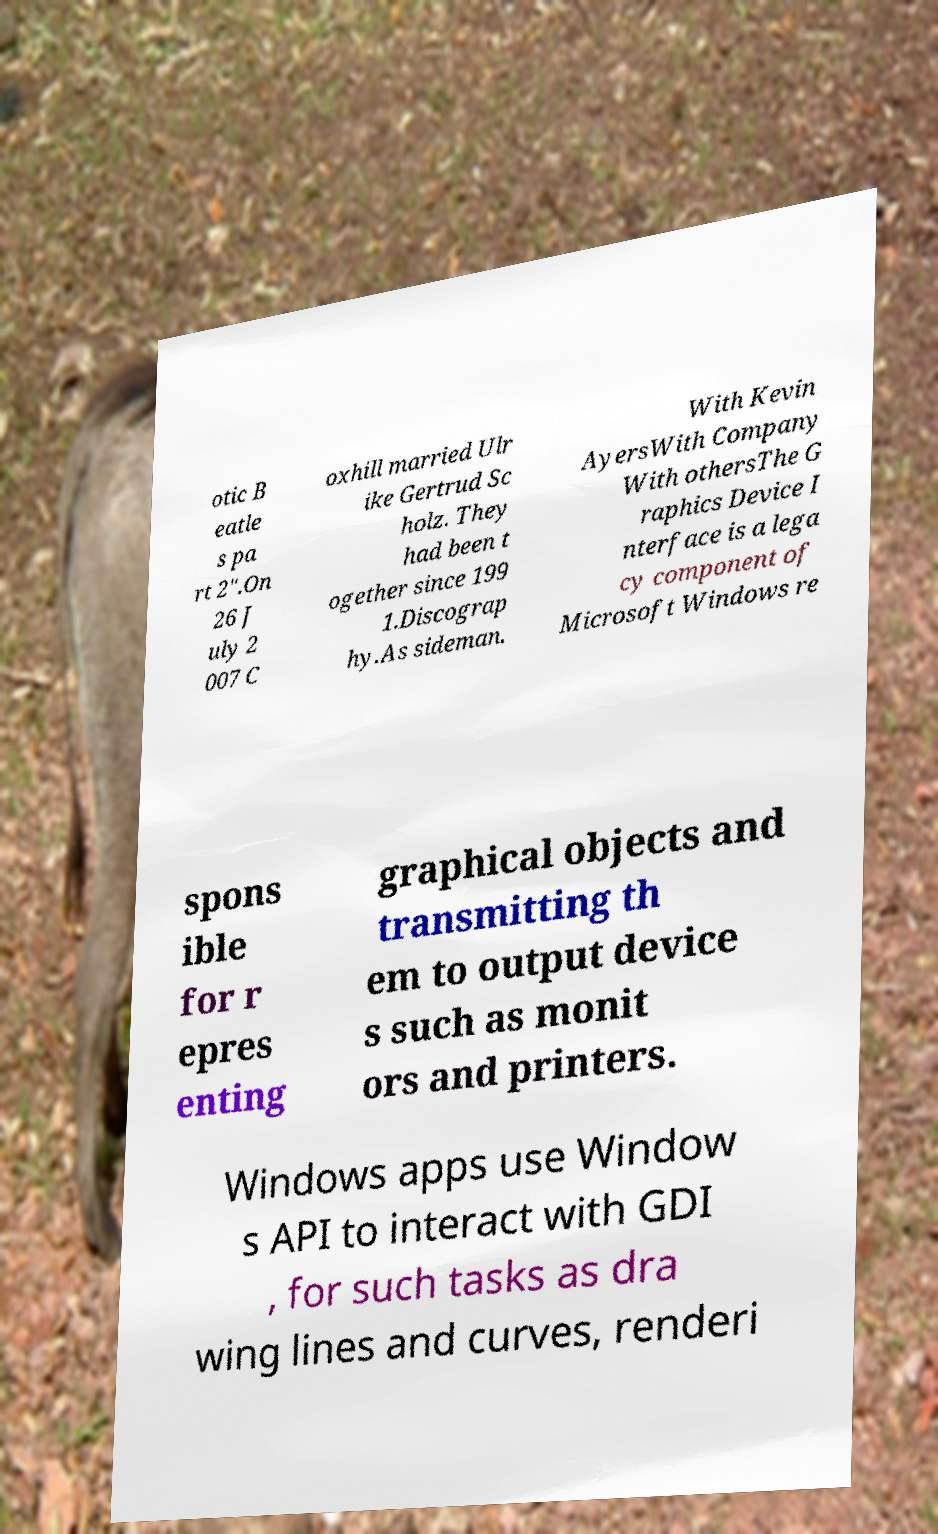Could you extract and type out the text from this image? otic B eatle s pa rt 2".On 26 J uly 2 007 C oxhill married Ulr ike Gertrud Sc holz. They had been t ogether since 199 1.Discograp hy.As sideman. With Kevin AyersWith Company With othersThe G raphics Device I nterface is a lega cy component of Microsoft Windows re spons ible for r epres enting graphical objects and transmitting th em to output device s such as monit ors and printers. Windows apps use Window s API to interact with GDI , for such tasks as dra wing lines and curves, renderi 